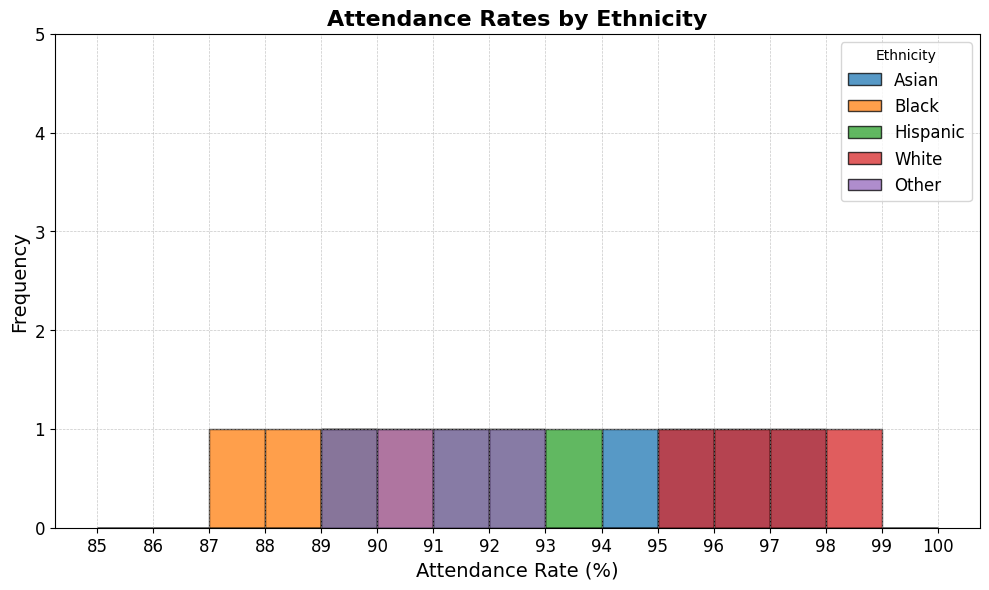What ethnicity has the highest attendance rate? By examining the histogram, the tallest bars representing the highest attendance rates fall in the categories marked for "White," specifically near 97-98%.
Answer: White What is the average attendance rate for the Black ethnicity? The attendance rates for Black students are 89, 88, 90, and 87. Adding these up: (89 + 88 + 90 + 87) = 354. Dividing by the number of data points (4) gives: 354 / 4 = 88.5.
Answer: 88.5 Which ethnicity has the most frequent attendance rate between 95% and 97%? Observing the histogram, the "Asian" and "White" ethnicities have multiple bars between 95% and 97%. Counting the bars, we see "Asian" has 3 bars (95, 96, 97) whereas "White" has 2 bars (95, 97). Therefore, Asian is more frequent.
Answer: Asian What is the difference between the highest attendance rate of Hispanic and Other ethnicities? The highest attendance rates for Hispanic and Other are 93% and 92%, respectively. The difference is 93 - 92 = 1.
Answer: 1 How do the attendance rates of Other ethnicity compare to Hispanic in the 89%-92% range? The "Other" ethnicity has attendance rates at 89, 90, 91, 92, while "Hispanic" has 89, 91, 92, 93. Therefore, both ethnicities are frequent in this range, but "Hispanic" goes one percent higher.
Answer: Similar, but Hispanic extends to 93% What color represents the Asian ethnicity in the histogram? The histogram uses different colors for each ethnicity. The color for the Asian ethnicity is marked by the bars labelled with attendance rates in the 94-97% range, which are shown in blue.
Answer: Blue Between Black and Hispanic, which ethnicity has a more consistent attendance rate? Consistency can be measured by the range of attendance rates. "Black" has rates from 87 to 90 (range 3), while "Hispanic" has rates from 89 to 93 (range 4). Thus, "Black" displays a more consistent attendance rate.
Answer: Black What is the frequency of 95% attendance rate for all ethnicities combined? Observing the histogram bars directly, 95% is seen in "Asian" and "White". Each has one count in the 95% bin. Summing these counts, the total frequency is 2.
Answer: 2 Which ethnicity has the least variation in attendance rates? Variation can be judged by the spread of bars in the histogram. The smallest spread is observed in Black ethnicity with rates ranging only from 87 to 90 (difference 3).
Answer: Black 